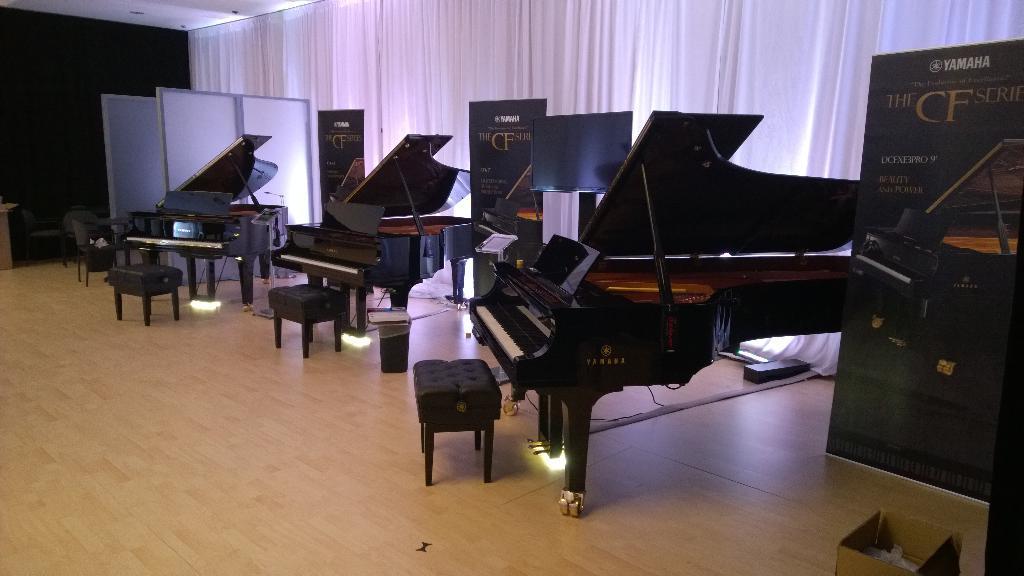Could you give a brief overview of what you see in this image? In the room there are three pianos and three chairs. To the right side there is a banner. There are three banners. In the background there are curtains with white color. 